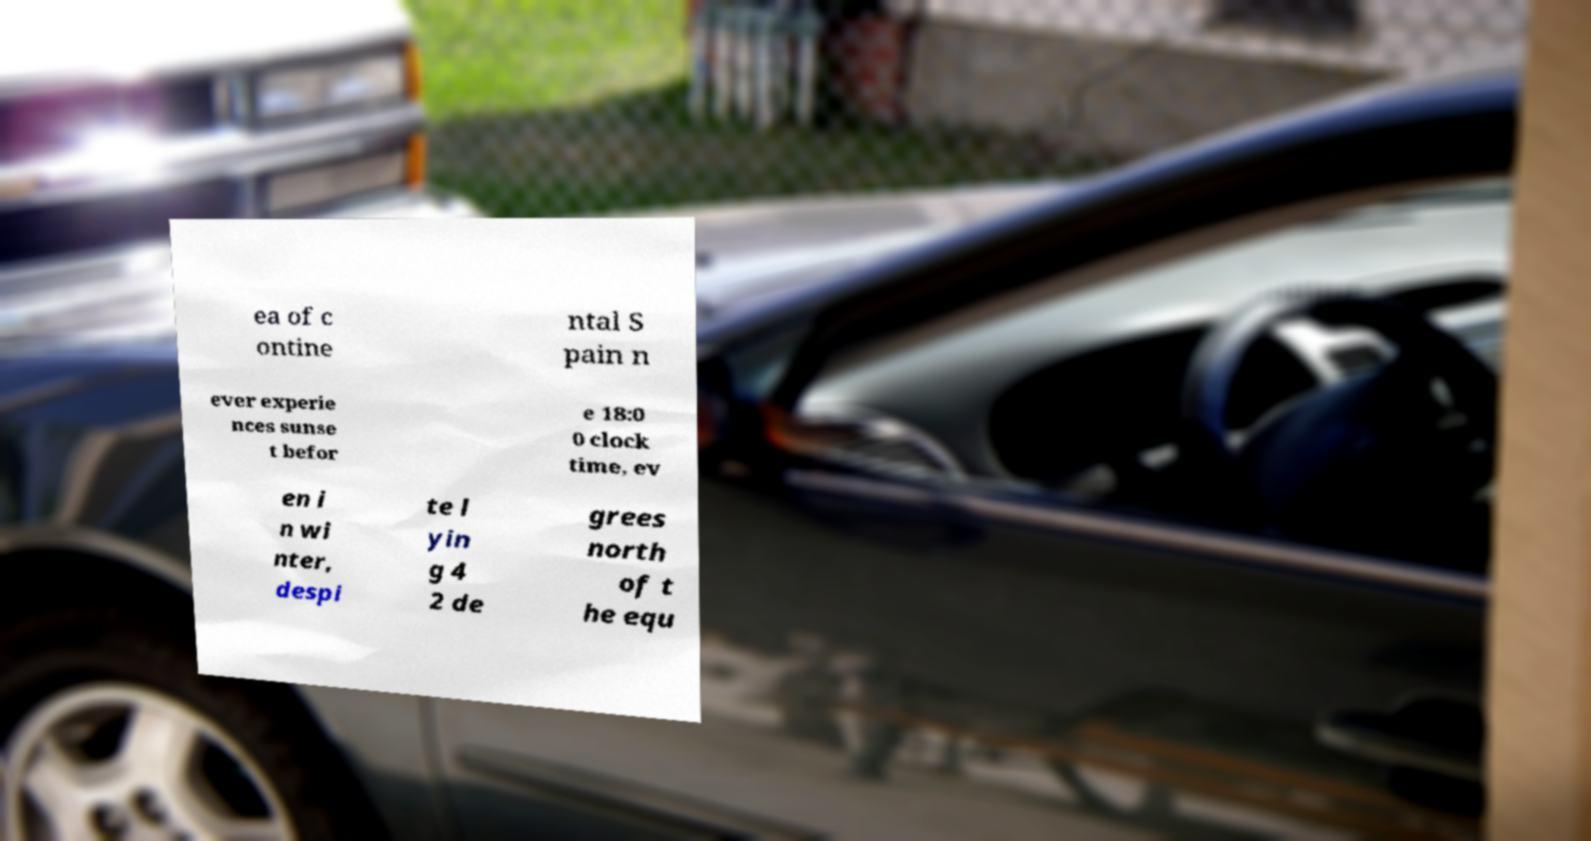Please read and relay the text visible in this image. What does it say? ea of c ontine ntal S pain n ever experie nces sunse t befor e 18:0 0 clock time, ev en i n wi nter, despi te l yin g 4 2 de grees north of t he equ 